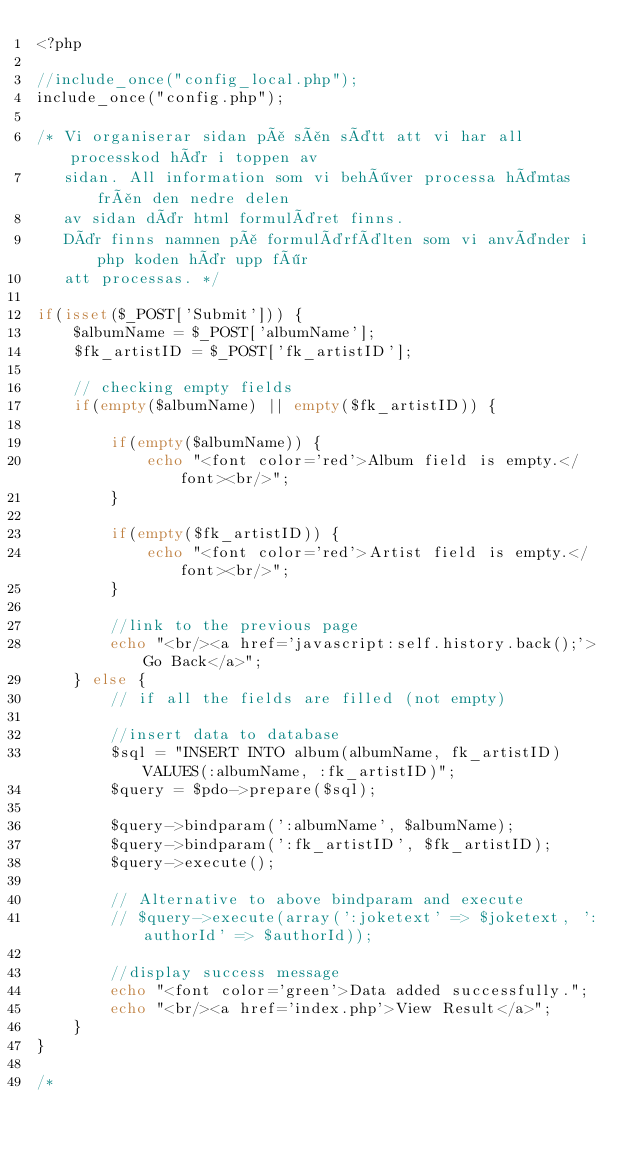Convert code to text. <code><loc_0><loc_0><loc_500><loc_500><_PHP_><?php

//include_once("config_local.php");
include_once("config.php");

/* Vi organiserar sidan på sån sätt att vi har all processkod här i toppen av
   sidan. All information som vi behöver processa hämtas från den nedre delen
   av sidan där html formuläret finns.
   Där finns namnen på formulärfälten som vi använder i php koden här upp för 
   att processas. */

if(isset($_POST['Submit'])) {    
    $albumName = $_POST['albumName'];
    $fk_artistID = $_POST['fk_artistID'];
        
    // checking empty fields
    if(empty($albumName) || empty($fk_artistID)) {
                
        if(empty($albumName)) {
            echo "<font color='red'>Album field is empty.</font><br/>";
        }
        
        if(empty($fk_artistID)) {
            echo "<font color='red'>Artist field is empty.</font><br/>";
        }
        
        //link to the previous page
        echo "<br/><a href='javascript:self.history.back();'>Go Back</a>";
    } else { 
        // if all the fields are filled (not empty) 
            
        //insert data to database        
        $sql = "INSERT INTO album(albumName, fk_artistID) VALUES(:albumName, :fk_artistID)";
        $query = $pdo->prepare($sql);
                
        $query->bindparam(':albumName', $albumName);
        $query->bindparam(':fk_artistID', $fk_artistID);
        $query->execute();
        
        // Alternative to above bindparam and execute
        // $query->execute(array(':joketext' => $joketext, ':authorId' => $authorId));
        
        //display success message
        echo "<font color='green'>Data added successfully.";
        echo "<br/><a href='index.php'>View Result</a>";
    }
}

/*</code> 